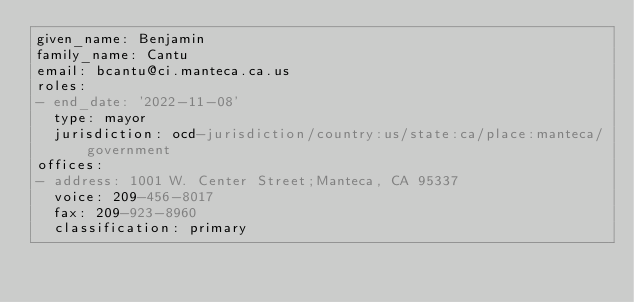<code> <loc_0><loc_0><loc_500><loc_500><_YAML_>given_name: Benjamin
family_name: Cantu
email: bcantu@ci.manteca.ca.us
roles:
- end_date: '2022-11-08'
  type: mayor
  jurisdiction: ocd-jurisdiction/country:us/state:ca/place:manteca/government
offices:
- address: 1001 W. Center Street;Manteca, CA 95337
  voice: 209-456-8017
  fax: 209-923-8960
  classification: primary
</code> 